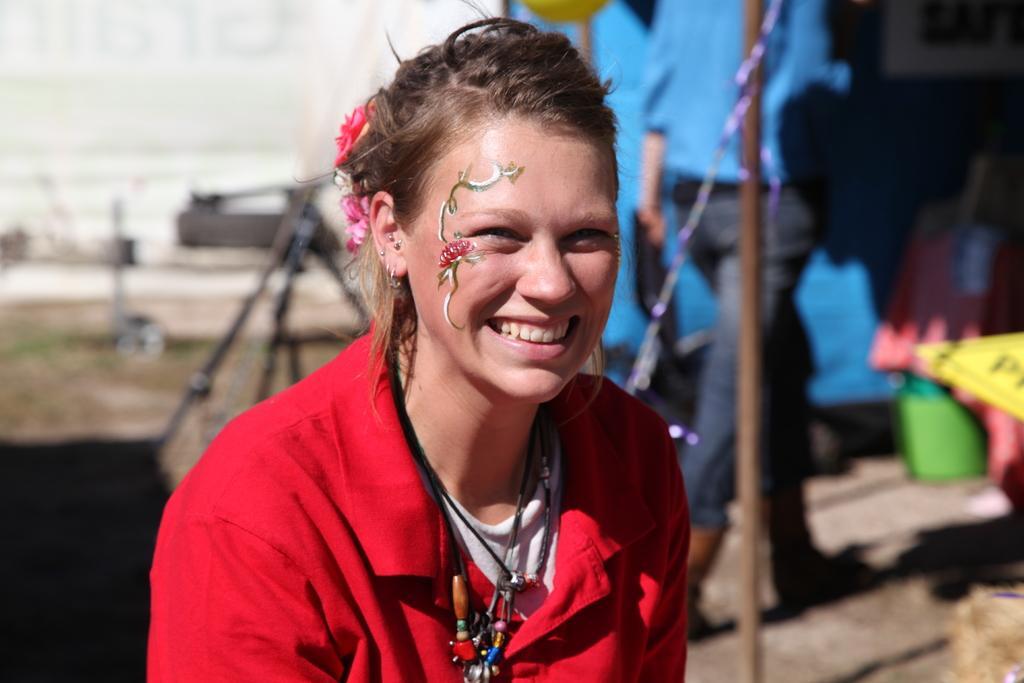In one or two sentences, can you explain what this image depicts? There is a lady wearing chains and smiling. On the face of the lady something is painted. On the hair of the lady there are flower. In the background it is blurred. Some people and a pole is there in the background. 